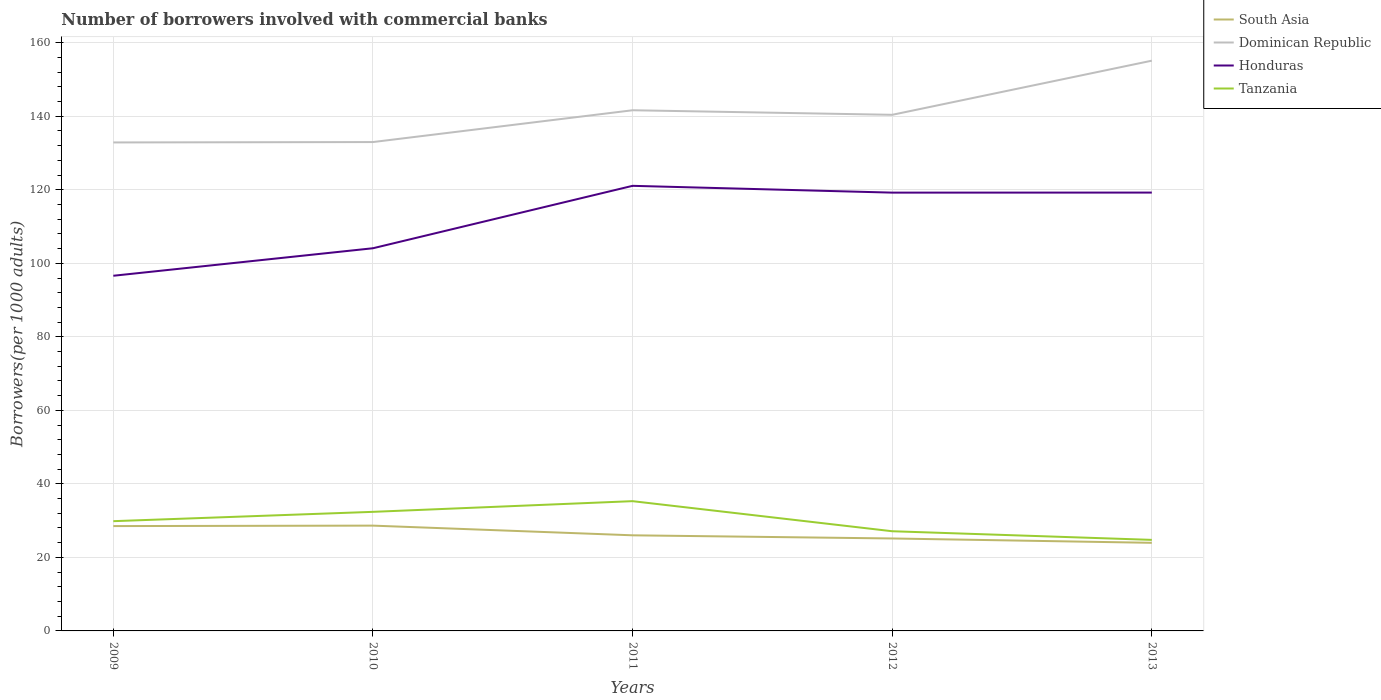How many different coloured lines are there?
Ensure brevity in your answer.  4. Across all years, what is the maximum number of borrowers involved with commercial banks in Honduras?
Provide a succinct answer. 96.61. What is the total number of borrowers involved with commercial banks in South Asia in the graph?
Provide a short and direct response. 3.49. What is the difference between the highest and the second highest number of borrowers involved with commercial banks in Honduras?
Provide a short and direct response. 24.46. What is the difference between the highest and the lowest number of borrowers involved with commercial banks in Dominican Republic?
Your answer should be very brief. 2. How many lines are there?
Your response must be concise. 4. What is the difference between two consecutive major ticks on the Y-axis?
Provide a succinct answer. 20. Are the values on the major ticks of Y-axis written in scientific E-notation?
Keep it short and to the point. No. Does the graph contain grids?
Ensure brevity in your answer.  Yes. Where does the legend appear in the graph?
Offer a terse response. Top right. How many legend labels are there?
Your response must be concise. 4. What is the title of the graph?
Ensure brevity in your answer.  Number of borrowers involved with commercial banks. Does "Germany" appear as one of the legend labels in the graph?
Keep it short and to the point. No. What is the label or title of the X-axis?
Offer a terse response. Years. What is the label or title of the Y-axis?
Your answer should be compact. Borrowers(per 1000 adults). What is the Borrowers(per 1000 adults) of South Asia in 2009?
Offer a very short reply. 28.52. What is the Borrowers(per 1000 adults) in Dominican Republic in 2009?
Offer a very short reply. 132.88. What is the Borrowers(per 1000 adults) of Honduras in 2009?
Your answer should be very brief. 96.61. What is the Borrowers(per 1000 adults) in Tanzania in 2009?
Offer a terse response. 29.86. What is the Borrowers(per 1000 adults) in South Asia in 2010?
Provide a short and direct response. 28.64. What is the Borrowers(per 1000 adults) in Dominican Republic in 2010?
Provide a short and direct response. 132.98. What is the Borrowers(per 1000 adults) of Honduras in 2010?
Give a very brief answer. 104.09. What is the Borrowers(per 1000 adults) in Tanzania in 2010?
Make the answer very short. 32.39. What is the Borrowers(per 1000 adults) of South Asia in 2011?
Give a very brief answer. 26.01. What is the Borrowers(per 1000 adults) in Dominican Republic in 2011?
Your answer should be very brief. 141.63. What is the Borrowers(per 1000 adults) in Honduras in 2011?
Ensure brevity in your answer.  121.07. What is the Borrowers(per 1000 adults) of Tanzania in 2011?
Your answer should be very brief. 35.3. What is the Borrowers(per 1000 adults) in South Asia in 2012?
Make the answer very short. 25.15. What is the Borrowers(per 1000 adults) in Dominican Republic in 2012?
Provide a short and direct response. 140.39. What is the Borrowers(per 1000 adults) of Honduras in 2012?
Make the answer very short. 119.22. What is the Borrowers(per 1000 adults) of Tanzania in 2012?
Your answer should be very brief. 27.12. What is the Borrowers(per 1000 adults) of South Asia in 2013?
Ensure brevity in your answer.  23.97. What is the Borrowers(per 1000 adults) of Dominican Republic in 2013?
Make the answer very short. 155.11. What is the Borrowers(per 1000 adults) of Honduras in 2013?
Provide a succinct answer. 119.24. What is the Borrowers(per 1000 adults) of Tanzania in 2013?
Keep it short and to the point. 24.77. Across all years, what is the maximum Borrowers(per 1000 adults) in South Asia?
Offer a terse response. 28.64. Across all years, what is the maximum Borrowers(per 1000 adults) in Dominican Republic?
Your answer should be compact. 155.11. Across all years, what is the maximum Borrowers(per 1000 adults) of Honduras?
Your answer should be compact. 121.07. Across all years, what is the maximum Borrowers(per 1000 adults) in Tanzania?
Provide a short and direct response. 35.3. Across all years, what is the minimum Borrowers(per 1000 adults) of South Asia?
Your response must be concise. 23.97. Across all years, what is the minimum Borrowers(per 1000 adults) in Dominican Republic?
Your answer should be compact. 132.88. Across all years, what is the minimum Borrowers(per 1000 adults) in Honduras?
Offer a very short reply. 96.61. Across all years, what is the minimum Borrowers(per 1000 adults) of Tanzania?
Keep it short and to the point. 24.77. What is the total Borrowers(per 1000 adults) of South Asia in the graph?
Offer a very short reply. 132.29. What is the total Borrowers(per 1000 adults) of Dominican Republic in the graph?
Offer a very short reply. 702.99. What is the total Borrowers(per 1000 adults) in Honduras in the graph?
Provide a succinct answer. 560.23. What is the total Borrowers(per 1000 adults) of Tanzania in the graph?
Your answer should be compact. 149.43. What is the difference between the Borrowers(per 1000 adults) in South Asia in 2009 and that in 2010?
Offer a very short reply. -0.12. What is the difference between the Borrowers(per 1000 adults) in Dominican Republic in 2009 and that in 2010?
Make the answer very short. -0.1. What is the difference between the Borrowers(per 1000 adults) of Honduras in 2009 and that in 2010?
Give a very brief answer. -7.48. What is the difference between the Borrowers(per 1000 adults) of Tanzania in 2009 and that in 2010?
Offer a terse response. -2.54. What is the difference between the Borrowers(per 1000 adults) in South Asia in 2009 and that in 2011?
Provide a short and direct response. 2.51. What is the difference between the Borrowers(per 1000 adults) in Dominican Republic in 2009 and that in 2011?
Your response must be concise. -8.75. What is the difference between the Borrowers(per 1000 adults) of Honduras in 2009 and that in 2011?
Give a very brief answer. -24.46. What is the difference between the Borrowers(per 1000 adults) of Tanzania in 2009 and that in 2011?
Make the answer very short. -5.44. What is the difference between the Borrowers(per 1000 adults) of South Asia in 2009 and that in 2012?
Provide a succinct answer. 3.37. What is the difference between the Borrowers(per 1000 adults) of Dominican Republic in 2009 and that in 2012?
Your response must be concise. -7.51. What is the difference between the Borrowers(per 1000 adults) in Honduras in 2009 and that in 2012?
Your response must be concise. -22.61. What is the difference between the Borrowers(per 1000 adults) in Tanzania in 2009 and that in 2012?
Make the answer very short. 2.74. What is the difference between the Borrowers(per 1000 adults) in South Asia in 2009 and that in 2013?
Provide a succinct answer. 4.55. What is the difference between the Borrowers(per 1000 adults) in Dominican Republic in 2009 and that in 2013?
Make the answer very short. -22.24. What is the difference between the Borrowers(per 1000 adults) of Honduras in 2009 and that in 2013?
Provide a short and direct response. -22.63. What is the difference between the Borrowers(per 1000 adults) in Tanzania in 2009 and that in 2013?
Offer a terse response. 5.09. What is the difference between the Borrowers(per 1000 adults) of South Asia in 2010 and that in 2011?
Provide a short and direct response. 2.63. What is the difference between the Borrowers(per 1000 adults) in Dominican Republic in 2010 and that in 2011?
Provide a short and direct response. -8.65. What is the difference between the Borrowers(per 1000 adults) in Honduras in 2010 and that in 2011?
Make the answer very short. -16.98. What is the difference between the Borrowers(per 1000 adults) of Tanzania in 2010 and that in 2011?
Offer a very short reply. -2.91. What is the difference between the Borrowers(per 1000 adults) in South Asia in 2010 and that in 2012?
Your response must be concise. 3.49. What is the difference between the Borrowers(per 1000 adults) of Dominican Republic in 2010 and that in 2012?
Your answer should be compact. -7.41. What is the difference between the Borrowers(per 1000 adults) of Honduras in 2010 and that in 2012?
Provide a succinct answer. -15.13. What is the difference between the Borrowers(per 1000 adults) of Tanzania in 2010 and that in 2012?
Offer a terse response. 5.28. What is the difference between the Borrowers(per 1000 adults) in South Asia in 2010 and that in 2013?
Your response must be concise. 4.68. What is the difference between the Borrowers(per 1000 adults) of Dominican Republic in 2010 and that in 2013?
Offer a terse response. -22.14. What is the difference between the Borrowers(per 1000 adults) in Honduras in 2010 and that in 2013?
Your answer should be very brief. -15.14. What is the difference between the Borrowers(per 1000 adults) of Tanzania in 2010 and that in 2013?
Your answer should be very brief. 7.63. What is the difference between the Borrowers(per 1000 adults) in South Asia in 2011 and that in 2012?
Your response must be concise. 0.86. What is the difference between the Borrowers(per 1000 adults) of Dominican Republic in 2011 and that in 2012?
Offer a very short reply. 1.24. What is the difference between the Borrowers(per 1000 adults) of Honduras in 2011 and that in 2012?
Your response must be concise. 1.85. What is the difference between the Borrowers(per 1000 adults) of Tanzania in 2011 and that in 2012?
Provide a succinct answer. 8.18. What is the difference between the Borrowers(per 1000 adults) in South Asia in 2011 and that in 2013?
Provide a succinct answer. 2.04. What is the difference between the Borrowers(per 1000 adults) in Dominican Republic in 2011 and that in 2013?
Keep it short and to the point. -13.49. What is the difference between the Borrowers(per 1000 adults) in Honduras in 2011 and that in 2013?
Keep it short and to the point. 1.84. What is the difference between the Borrowers(per 1000 adults) in Tanzania in 2011 and that in 2013?
Your answer should be very brief. 10.53. What is the difference between the Borrowers(per 1000 adults) in South Asia in 2012 and that in 2013?
Your answer should be very brief. 1.18. What is the difference between the Borrowers(per 1000 adults) of Dominican Republic in 2012 and that in 2013?
Your answer should be very brief. -14.72. What is the difference between the Borrowers(per 1000 adults) of Honduras in 2012 and that in 2013?
Offer a very short reply. -0.02. What is the difference between the Borrowers(per 1000 adults) of Tanzania in 2012 and that in 2013?
Make the answer very short. 2.35. What is the difference between the Borrowers(per 1000 adults) of South Asia in 2009 and the Borrowers(per 1000 adults) of Dominican Republic in 2010?
Keep it short and to the point. -104.46. What is the difference between the Borrowers(per 1000 adults) in South Asia in 2009 and the Borrowers(per 1000 adults) in Honduras in 2010?
Your answer should be compact. -75.57. What is the difference between the Borrowers(per 1000 adults) in South Asia in 2009 and the Borrowers(per 1000 adults) in Tanzania in 2010?
Your response must be concise. -3.87. What is the difference between the Borrowers(per 1000 adults) of Dominican Republic in 2009 and the Borrowers(per 1000 adults) of Honduras in 2010?
Your answer should be compact. 28.78. What is the difference between the Borrowers(per 1000 adults) in Dominican Republic in 2009 and the Borrowers(per 1000 adults) in Tanzania in 2010?
Your answer should be very brief. 100.48. What is the difference between the Borrowers(per 1000 adults) of Honduras in 2009 and the Borrowers(per 1000 adults) of Tanzania in 2010?
Give a very brief answer. 64.22. What is the difference between the Borrowers(per 1000 adults) in South Asia in 2009 and the Borrowers(per 1000 adults) in Dominican Republic in 2011?
Make the answer very short. -113.11. What is the difference between the Borrowers(per 1000 adults) in South Asia in 2009 and the Borrowers(per 1000 adults) in Honduras in 2011?
Provide a short and direct response. -92.55. What is the difference between the Borrowers(per 1000 adults) of South Asia in 2009 and the Borrowers(per 1000 adults) of Tanzania in 2011?
Keep it short and to the point. -6.78. What is the difference between the Borrowers(per 1000 adults) in Dominican Republic in 2009 and the Borrowers(per 1000 adults) in Honduras in 2011?
Ensure brevity in your answer.  11.8. What is the difference between the Borrowers(per 1000 adults) of Dominican Republic in 2009 and the Borrowers(per 1000 adults) of Tanzania in 2011?
Provide a short and direct response. 97.58. What is the difference between the Borrowers(per 1000 adults) of Honduras in 2009 and the Borrowers(per 1000 adults) of Tanzania in 2011?
Provide a succinct answer. 61.31. What is the difference between the Borrowers(per 1000 adults) in South Asia in 2009 and the Borrowers(per 1000 adults) in Dominican Republic in 2012?
Provide a succinct answer. -111.87. What is the difference between the Borrowers(per 1000 adults) of South Asia in 2009 and the Borrowers(per 1000 adults) of Honduras in 2012?
Your answer should be very brief. -90.7. What is the difference between the Borrowers(per 1000 adults) of South Asia in 2009 and the Borrowers(per 1000 adults) of Tanzania in 2012?
Give a very brief answer. 1.41. What is the difference between the Borrowers(per 1000 adults) in Dominican Republic in 2009 and the Borrowers(per 1000 adults) in Honduras in 2012?
Offer a very short reply. 13.65. What is the difference between the Borrowers(per 1000 adults) of Dominican Republic in 2009 and the Borrowers(per 1000 adults) of Tanzania in 2012?
Your response must be concise. 105.76. What is the difference between the Borrowers(per 1000 adults) in Honduras in 2009 and the Borrowers(per 1000 adults) in Tanzania in 2012?
Ensure brevity in your answer.  69.49. What is the difference between the Borrowers(per 1000 adults) in South Asia in 2009 and the Borrowers(per 1000 adults) in Dominican Republic in 2013?
Offer a very short reply. -126.59. What is the difference between the Borrowers(per 1000 adults) in South Asia in 2009 and the Borrowers(per 1000 adults) in Honduras in 2013?
Make the answer very short. -90.72. What is the difference between the Borrowers(per 1000 adults) of South Asia in 2009 and the Borrowers(per 1000 adults) of Tanzania in 2013?
Keep it short and to the point. 3.76. What is the difference between the Borrowers(per 1000 adults) in Dominican Republic in 2009 and the Borrowers(per 1000 adults) in Honduras in 2013?
Offer a terse response. 13.64. What is the difference between the Borrowers(per 1000 adults) in Dominican Republic in 2009 and the Borrowers(per 1000 adults) in Tanzania in 2013?
Give a very brief answer. 108.11. What is the difference between the Borrowers(per 1000 adults) in Honduras in 2009 and the Borrowers(per 1000 adults) in Tanzania in 2013?
Your answer should be very brief. 71.84. What is the difference between the Borrowers(per 1000 adults) in South Asia in 2010 and the Borrowers(per 1000 adults) in Dominican Republic in 2011?
Provide a short and direct response. -112.99. What is the difference between the Borrowers(per 1000 adults) in South Asia in 2010 and the Borrowers(per 1000 adults) in Honduras in 2011?
Provide a short and direct response. -92.43. What is the difference between the Borrowers(per 1000 adults) of South Asia in 2010 and the Borrowers(per 1000 adults) of Tanzania in 2011?
Your answer should be compact. -6.66. What is the difference between the Borrowers(per 1000 adults) of Dominican Republic in 2010 and the Borrowers(per 1000 adults) of Honduras in 2011?
Offer a very short reply. 11.91. What is the difference between the Borrowers(per 1000 adults) in Dominican Republic in 2010 and the Borrowers(per 1000 adults) in Tanzania in 2011?
Your response must be concise. 97.68. What is the difference between the Borrowers(per 1000 adults) in Honduras in 2010 and the Borrowers(per 1000 adults) in Tanzania in 2011?
Your answer should be very brief. 68.8. What is the difference between the Borrowers(per 1000 adults) of South Asia in 2010 and the Borrowers(per 1000 adults) of Dominican Republic in 2012?
Offer a terse response. -111.75. What is the difference between the Borrowers(per 1000 adults) in South Asia in 2010 and the Borrowers(per 1000 adults) in Honduras in 2012?
Make the answer very short. -90.58. What is the difference between the Borrowers(per 1000 adults) in South Asia in 2010 and the Borrowers(per 1000 adults) in Tanzania in 2012?
Give a very brief answer. 1.53. What is the difference between the Borrowers(per 1000 adults) in Dominican Republic in 2010 and the Borrowers(per 1000 adults) in Honduras in 2012?
Offer a very short reply. 13.76. What is the difference between the Borrowers(per 1000 adults) of Dominican Republic in 2010 and the Borrowers(per 1000 adults) of Tanzania in 2012?
Make the answer very short. 105.86. What is the difference between the Borrowers(per 1000 adults) of Honduras in 2010 and the Borrowers(per 1000 adults) of Tanzania in 2012?
Make the answer very short. 76.98. What is the difference between the Borrowers(per 1000 adults) in South Asia in 2010 and the Borrowers(per 1000 adults) in Dominican Republic in 2013?
Give a very brief answer. -126.47. What is the difference between the Borrowers(per 1000 adults) in South Asia in 2010 and the Borrowers(per 1000 adults) in Honduras in 2013?
Provide a short and direct response. -90.6. What is the difference between the Borrowers(per 1000 adults) of South Asia in 2010 and the Borrowers(per 1000 adults) of Tanzania in 2013?
Keep it short and to the point. 3.88. What is the difference between the Borrowers(per 1000 adults) in Dominican Republic in 2010 and the Borrowers(per 1000 adults) in Honduras in 2013?
Your answer should be compact. 13.74. What is the difference between the Borrowers(per 1000 adults) in Dominican Republic in 2010 and the Borrowers(per 1000 adults) in Tanzania in 2013?
Provide a succinct answer. 108.21. What is the difference between the Borrowers(per 1000 adults) of Honduras in 2010 and the Borrowers(per 1000 adults) of Tanzania in 2013?
Your response must be concise. 79.33. What is the difference between the Borrowers(per 1000 adults) in South Asia in 2011 and the Borrowers(per 1000 adults) in Dominican Republic in 2012?
Your answer should be compact. -114.38. What is the difference between the Borrowers(per 1000 adults) of South Asia in 2011 and the Borrowers(per 1000 adults) of Honduras in 2012?
Offer a terse response. -93.21. What is the difference between the Borrowers(per 1000 adults) of South Asia in 2011 and the Borrowers(per 1000 adults) of Tanzania in 2012?
Make the answer very short. -1.11. What is the difference between the Borrowers(per 1000 adults) of Dominican Republic in 2011 and the Borrowers(per 1000 adults) of Honduras in 2012?
Keep it short and to the point. 22.41. What is the difference between the Borrowers(per 1000 adults) in Dominican Republic in 2011 and the Borrowers(per 1000 adults) in Tanzania in 2012?
Make the answer very short. 114.51. What is the difference between the Borrowers(per 1000 adults) in Honduras in 2011 and the Borrowers(per 1000 adults) in Tanzania in 2012?
Ensure brevity in your answer.  93.96. What is the difference between the Borrowers(per 1000 adults) of South Asia in 2011 and the Borrowers(per 1000 adults) of Dominican Republic in 2013?
Offer a terse response. -129.11. What is the difference between the Borrowers(per 1000 adults) in South Asia in 2011 and the Borrowers(per 1000 adults) in Honduras in 2013?
Your answer should be very brief. -93.23. What is the difference between the Borrowers(per 1000 adults) in South Asia in 2011 and the Borrowers(per 1000 adults) in Tanzania in 2013?
Your answer should be very brief. 1.24. What is the difference between the Borrowers(per 1000 adults) in Dominican Republic in 2011 and the Borrowers(per 1000 adults) in Honduras in 2013?
Make the answer very short. 22.39. What is the difference between the Borrowers(per 1000 adults) in Dominican Republic in 2011 and the Borrowers(per 1000 adults) in Tanzania in 2013?
Offer a terse response. 116.86. What is the difference between the Borrowers(per 1000 adults) of Honduras in 2011 and the Borrowers(per 1000 adults) of Tanzania in 2013?
Your answer should be very brief. 96.31. What is the difference between the Borrowers(per 1000 adults) of South Asia in 2012 and the Borrowers(per 1000 adults) of Dominican Republic in 2013?
Your response must be concise. -129.97. What is the difference between the Borrowers(per 1000 adults) of South Asia in 2012 and the Borrowers(per 1000 adults) of Honduras in 2013?
Keep it short and to the point. -94.09. What is the difference between the Borrowers(per 1000 adults) of South Asia in 2012 and the Borrowers(per 1000 adults) of Tanzania in 2013?
Provide a succinct answer. 0.38. What is the difference between the Borrowers(per 1000 adults) in Dominican Republic in 2012 and the Borrowers(per 1000 adults) in Honduras in 2013?
Give a very brief answer. 21.15. What is the difference between the Borrowers(per 1000 adults) of Dominican Republic in 2012 and the Borrowers(per 1000 adults) of Tanzania in 2013?
Make the answer very short. 115.63. What is the difference between the Borrowers(per 1000 adults) in Honduras in 2012 and the Borrowers(per 1000 adults) in Tanzania in 2013?
Your response must be concise. 94.46. What is the average Borrowers(per 1000 adults) in South Asia per year?
Your answer should be compact. 26.46. What is the average Borrowers(per 1000 adults) in Dominican Republic per year?
Your answer should be very brief. 140.6. What is the average Borrowers(per 1000 adults) in Honduras per year?
Offer a terse response. 112.05. What is the average Borrowers(per 1000 adults) in Tanzania per year?
Offer a very short reply. 29.89. In the year 2009, what is the difference between the Borrowers(per 1000 adults) in South Asia and Borrowers(per 1000 adults) in Dominican Republic?
Offer a terse response. -104.36. In the year 2009, what is the difference between the Borrowers(per 1000 adults) of South Asia and Borrowers(per 1000 adults) of Honduras?
Your response must be concise. -68.09. In the year 2009, what is the difference between the Borrowers(per 1000 adults) of South Asia and Borrowers(per 1000 adults) of Tanzania?
Make the answer very short. -1.33. In the year 2009, what is the difference between the Borrowers(per 1000 adults) of Dominican Republic and Borrowers(per 1000 adults) of Honduras?
Ensure brevity in your answer.  36.27. In the year 2009, what is the difference between the Borrowers(per 1000 adults) in Dominican Republic and Borrowers(per 1000 adults) in Tanzania?
Offer a terse response. 103.02. In the year 2009, what is the difference between the Borrowers(per 1000 adults) in Honduras and Borrowers(per 1000 adults) in Tanzania?
Your answer should be compact. 66.75. In the year 2010, what is the difference between the Borrowers(per 1000 adults) of South Asia and Borrowers(per 1000 adults) of Dominican Republic?
Make the answer very short. -104.34. In the year 2010, what is the difference between the Borrowers(per 1000 adults) of South Asia and Borrowers(per 1000 adults) of Honduras?
Offer a very short reply. -75.45. In the year 2010, what is the difference between the Borrowers(per 1000 adults) of South Asia and Borrowers(per 1000 adults) of Tanzania?
Provide a short and direct response. -3.75. In the year 2010, what is the difference between the Borrowers(per 1000 adults) in Dominican Republic and Borrowers(per 1000 adults) in Honduras?
Your answer should be very brief. 28.89. In the year 2010, what is the difference between the Borrowers(per 1000 adults) in Dominican Republic and Borrowers(per 1000 adults) in Tanzania?
Ensure brevity in your answer.  100.59. In the year 2010, what is the difference between the Borrowers(per 1000 adults) of Honduras and Borrowers(per 1000 adults) of Tanzania?
Your answer should be compact. 71.7. In the year 2011, what is the difference between the Borrowers(per 1000 adults) of South Asia and Borrowers(per 1000 adults) of Dominican Republic?
Give a very brief answer. -115.62. In the year 2011, what is the difference between the Borrowers(per 1000 adults) in South Asia and Borrowers(per 1000 adults) in Honduras?
Your answer should be compact. -95.06. In the year 2011, what is the difference between the Borrowers(per 1000 adults) of South Asia and Borrowers(per 1000 adults) of Tanzania?
Your response must be concise. -9.29. In the year 2011, what is the difference between the Borrowers(per 1000 adults) of Dominican Republic and Borrowers(per 1000 adults) of Honduras?
Provide a succinct answer. 20.56. In the year 2011, what is the difference between the Borrowers(per 1000 adults) in Dominican Republic and Borrowers(per 1000 adults) in Tanzania?
Keep it short and to the point. 106.33. In the year 2011, what is the difference between the Borrowers(per 1000 adults) of Honduras and Borrowers(per 1000 adults) of Tanzania?
Keep it short and to the point. 85.77. In the year 2012, what is the difference between the Borrowers(per 1000 adults) of South Asia and Borrowers(per 1000 adults) of Dominican Republic?
Your answer should be compact. -115.24. In the year 2012, what is the difference between the Borrowers(per 1000 adults) of South Asia and Borrowers(per 1000 adults) of Honduras?
Give a very brief answer. -94.07. In the year 2012, what is the difference between the Borrowers(per 1000 adults) in South Asia and Borrowers(per 1000 adults) in Tanzania?
Offer a terse response. -1.97. In the year 2012, what is the difference between the Borrowers(per 1000 adults) of Dominican Republic and Borrowers(per 1000 adults) of Honduras?
Keep it short and to the point. 21.17. In the year 2012, what is the difference between the Borrowers(per 1000 adults) in Dominican Republic and Borrowers(per 1000 adults) in Tanzania?
Give a very brief answer. 113.28. In the year 2012, what is the difference between the Borrowers(per 1000 adults) of Honduras and Borrowers(per 1000 adults) of Tanzania?
Your answer should be compact. 92.11. In the year 2013, what is the difference between the Borrowers(per 1000 adults) of South Asia and Borrowers(per 1000 adults) of Dominican Republic?
Offer a very short reply. -131.15. In the year 2013, what is the difference between the Borrowers(per 1000 adults) of South Asia and Borrowers(per 1000 adults) of Honduras?
Offer a terse response. -95.27. In the year 2013, what is the difference between the Borrowers(per 1000 adults) of South Asia and Borrowers(per 1000 adults) of Tanzania?
Ensure brevity in your answer.  -0.8. In the year 2013, what is the difference between the Borrowers(per 1000 adults) in Dominican Republic and Borrowers(per 1000 adults) in Honduras?
Offer a very short reply. 35.88. In the year 2013, what is the difference between the Borrowers(per 1000 adults) of Dominican Republic and Borrowers(per 1000 adults) of Tanzania?
Provide a short and direct response. 130.35. In the year 2013, what is the difference between the Borrowers(per 1000 adults) of Honduras and Borrowers(per 1000 adults) of Tanzania?
Ensure brevity in your answer.  94.47. What is the ratio of the Borrowers(per 1000 adults) of South Asia in 2009 to that in 2010?
Ensure brevity in your answer.  1. What is the ratio of the Borrowers(per 1000 adults) of Dominican Republic in 2009 to that in 2010?
Keep it short and to the point. 1. What is the ratio of the Borrowers(per 1000 adults) in Honduras in 2009 to that in 2010?
Offer a very short reply. 0.93. What is the ratio of the Borrowers(per 1000 adults) of Tanzania in 2009 to that in 2010?
Provide a succinct answer. 0.92. What is the ratio of the Borrowers(per 1000 adults) of South Asia in 2009 to that in 2011?
Keep it short and to the point. 1.1. What is the ratio of the Borrowers(per 1000 adults) of Dominican Republic in 2009 to that in 2011?
Your answer should be compact. 0.94. What is the ratio of the Borrowers(per 1000 adults) of Honduras in 2009 to that in 2011?
Your response must be concise. 0.8. What is the ratio of the Borrowers(per 1000 adults) in Tanzania in 2009 to that in 2011?
Provide a short and direct response. 0.85. What is the ratio of the Borrowers(per 1000 adults) of South Asia in 2009 to that in 2012?
Your answer should be compact. 1.13. What is the ratio of the Borrowers(per 1000 adults) of Dominican Republic in 2009 to that in 2012?
Give a very brief answer. 0.95. What is the ratio of the Borrowers(per 1000 adults) of Honduras in 2009 to that in 2012?
Your answer should be compact. 0.81. What is the ratio of the Borrowers(per 1000 adults) in Tanzania in 2009 to that in 2012?
Provide a short and direct response. 1.1. What is the ratio of the Borrowers(per 1000 adults) in South Asia in 2009 to that in 2013?
Make the answer very short. 1.19. What is the ratio of the Borrowers(per 1000 adults) of Dominican Republic in 2009 to that in 2013?
Your response must be concise. 0.86. What is the ratio of the Borrowers(per 1000 adults) of Honduras in 2009 to that in 2013?
Give a very brief answer. 0.81. What is the ratio of the Borrowers(per 1000 adults) of Tanzania in 2009 to that in 2013?
Ensure brevity in your answer.  1.21. What is the ratio of the Borrowers(per 1000 adults) in South Asia in 2010 to that in 2011?
Make the answer very short. 1.1. What is the ratio of the Borrowers(per 1000 adults) in Dominican Republic in 2010 to that in 2011?
Offer a very short reply. 0.94. What is the ratio of the Borrowers(per 1000 adults) in Honduras in 2010 to that in 2011?
Give a very brief answer. 0.86. What is the ratio of the Borrowers(per 1000 adults) in Tanzania in 2010 to that in 2011?
Offer a very short reply. 0.92. What is the ratio of the Borrowers(per 1000 adults) of South Asia in 2010 to that in 2012?
Keep it short and to the point. 1.14. What is the ratio of the Borrowers(per 1000 adults) in Dominican Republic in 2010 to that in 2012?
Make the answer very short. 0.95. What is the ratio of the Borrowers(per 1000 adults) of Honduras in 2010 to that in 2012?
Offer a terse response. 0.87. What is the ratio of the Borrowers(per 1000 adults) of Tanzania in 2010 to that in 2012?
Keep it short and to the point. 1.19. What is the ratio of the Borrowers(per 1000 adults) of South Asia in 2010 to that in 2013?
Ensure brevity in your answer.  1.2. What is the ratio of the Borrowers(per 1000 adults) of Dominican Republic in 2010 to that in 2013?
Your answer should be compact. 0.86. What is the ratio of the Borrowers(per 1000 adults) in Honduras in 2010 to that in 2013?
Give a very brief answer. 0.87. What is the ratio of the Borrowers(per 1000 adults) of Tanzania in 2010 to that in 2013?
Offer a very short reply. 1.31. What is the ratio of the Borrowers(per 1000 adults) of South Asia in 2011 to that in 2012?
Give a very brief answer. 1.03. What is the ratio of the Borrowers(per 1000 adults) of Dominican Republic in 2011 to that in 2012?
Your response must be concise. 1.01. What is the ratio of the Borrowers(per 1000 adults) of Honduras in 2011 to that in 2012?
Ensure brevity in your answer.  1.02. What is the ratio of the Borrowers(per 1000 adults) of Tanzania in 2011 to that in 2012?
Provide a succinct answer. 1.3. What is the ratio of the Borrowers(per 1000 adults) in South Asia in 2011 to that in 2013?
Give a very brief answer. 1.09. What is the ratio of the Borrowers(per 1000 adults) of Dominican Republic in 2011 to that in 2013?
Give a very brief answer. 0.91. What is the ratio of the Borrowers(per 1000 adults) in Honduras in 2011 to that in 2013?
Your answer should be compact. 1.02. What is the ratio of the Borrowers(per 1000 adults) of Tanzania in 2011 to that in 2013?
Your response must be concise. 1.43. What is the ratio of the Borrowers(per 1000 adults) in South Asia in 2012 to that in 2013?
Make the answer very short. 1.05. What is the ratio of the Borrowers(per 1000 adults) in Dominican Republic in 2012 to that in 2013?
Provide a succinct answer. 0.91. What is the ratio of the Borrowers(per 1000 adults) in Tanzania in 2012 to that in 2013?
Make the answer very short. 1.09. What is the difference between the highest and the second highest Borrowers(per 1000 adults) in South Asia?
Make the answer very short. 0.12. What is the difference between the highest and the second highest Borrowers(per 1000 adults) of Dominican Republic?
Make the answer very short. 13.49. What is the difference between the highest and the second highest Borrowers(per 1000 adults) of Honduras?
Offer a very short reply. 1.84. What is the difference between the highest and the second highest Borrowers(per 1000 adults) in Tanzania?
Your answer should be compact. 2.91. What is the difference between the highest and the lowest Borrowers(per 1000 adults) in South Asia?
Your answer should be compact. 4.68. What is the difference between the highest and the lowest Borrowers(per 1000 adults) in Dominican Republic?
Your answer should be very brief. 22.24. What is the difference between the highest and the lowest Borrowers(per 1000 adults) of Honduras?
Offer a terse response. 24.46. What is the difference between the highest and the lowest Borrowers(per 1000 adults) in Tanzania?
Make the answer very short. 10.53. 